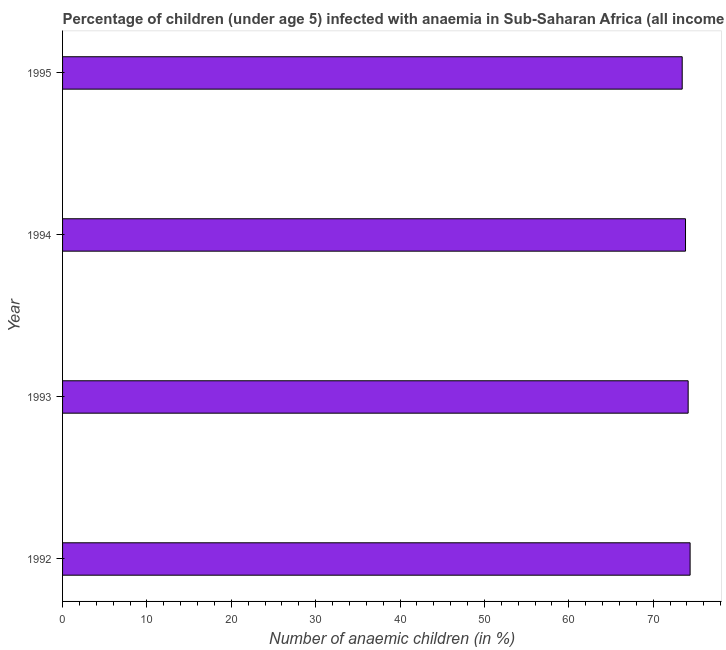Does the graph contain grids?
Keep it short and to the point. No. What is the title of the graph?
Make the answer very short. Percentage of children (under age 5) infected with anaemia in Sub-Saharan Africa (all income levels). What is the label or title of the X-axis?
Make the answer very short. Number of anaemic children (in %). What is the label or title of the Y-axis?
Ensure brevity in your answer.  Year. What is the number of anaemic children in 1993?
Provide a short and direct response. 74.15. Across all years, what is the maximum number of anaemic children?
Ensure brevity in your answer.  74.38. Across all years, what is the minimum number of anaemic children?
Ensure brevity in your answer.  73.44. In which year was the number of anaemic children maximum?
Keep it short and to the point. 1992. What is the sum of the number of anaemic children?
Offer a terse response. 295.8. What is the difference between the number of anaemic children in 1993 and 1994?
Offer a very short reply. 0.31. What is the average number of anaemic children per year?
Keep it short and to the point. 73.95. What is the median number of anaemic children?
Offer a terse response. 73.99. In how many years, is the number of anaemic children greater than 62 %?
Offer a very short reply. 4. What is the ratio of the number of anaemic children in 1993 to that in 1995?
Provide a short and direct response. 1.01. Is the number of anaemic children in 1993 less than that in 1994?
Your answer should be very brief. No. What is the difference between the highest and the second highest number of anaemic children?
Your answer should be very brief. 0.23. Is the sum of the number of anaemic children in 1993 and 1995 greater than the maximum number of anaemic children across all years?
Provide a short and direct response. Yes. In how many years, is the number of anaemic children greater than the average number of anaemic children taken over all years?
Make the answer very short. 2. How many bars are there?
Offer a terse response. 4. How many years are there in the graph?
Keep it short and to the point. 4. What is the difference between two consecutive major ticks on the X-axis?
Provide a succinct answer. 10. Are the values on the major ticks of X-axis written in scientific E-notation?
Offer a very short reply. No. What is the Number of anaemic children (in %) in 1992?
Your answer should be compact. 74.38. What is the Number of anaemic children (in %) in 1993?
Your answer should be very brief. 74.15. What is the Number of anaemic children (in %) in 1994?
Give a very brief answer. 73.83. What is the Number of anaemic children (in %) of 1995?
Give a very brief answer. 73.44. What is the difference between the Number of anaemic children (in %) in 1992 and 1993?
Your answer should be compact. 0.23. What is the difference between the Number of anaemic children (in %) in 1992 and 1994?
Offer a terse response. 0.54. What is the difference between the Number of anaemic children (in %) in 1992 and 1995?
Offer a very short reply. 0.94. What is the difference between the Number of anaemic children (in %) in 1993 and 1994?
Offer a very short reply. 0.31. What is the difference between the Number of anaemic children (in %) in 1993 and 1995?
Your response must be concise. 0.71. What is the difference between the Number of anaemic children (in %) in 1994 and 1995?
Your answer should be very brief. 0.39. What is the ratio of the Number of anaemic children (in %) in 1992 to that in 1993?
Provide a short and direct response. 1. What is the ratio of the Number of anaemic children (in %) in 1992 to that in 1995?
Make the answer very short. 1.01. 